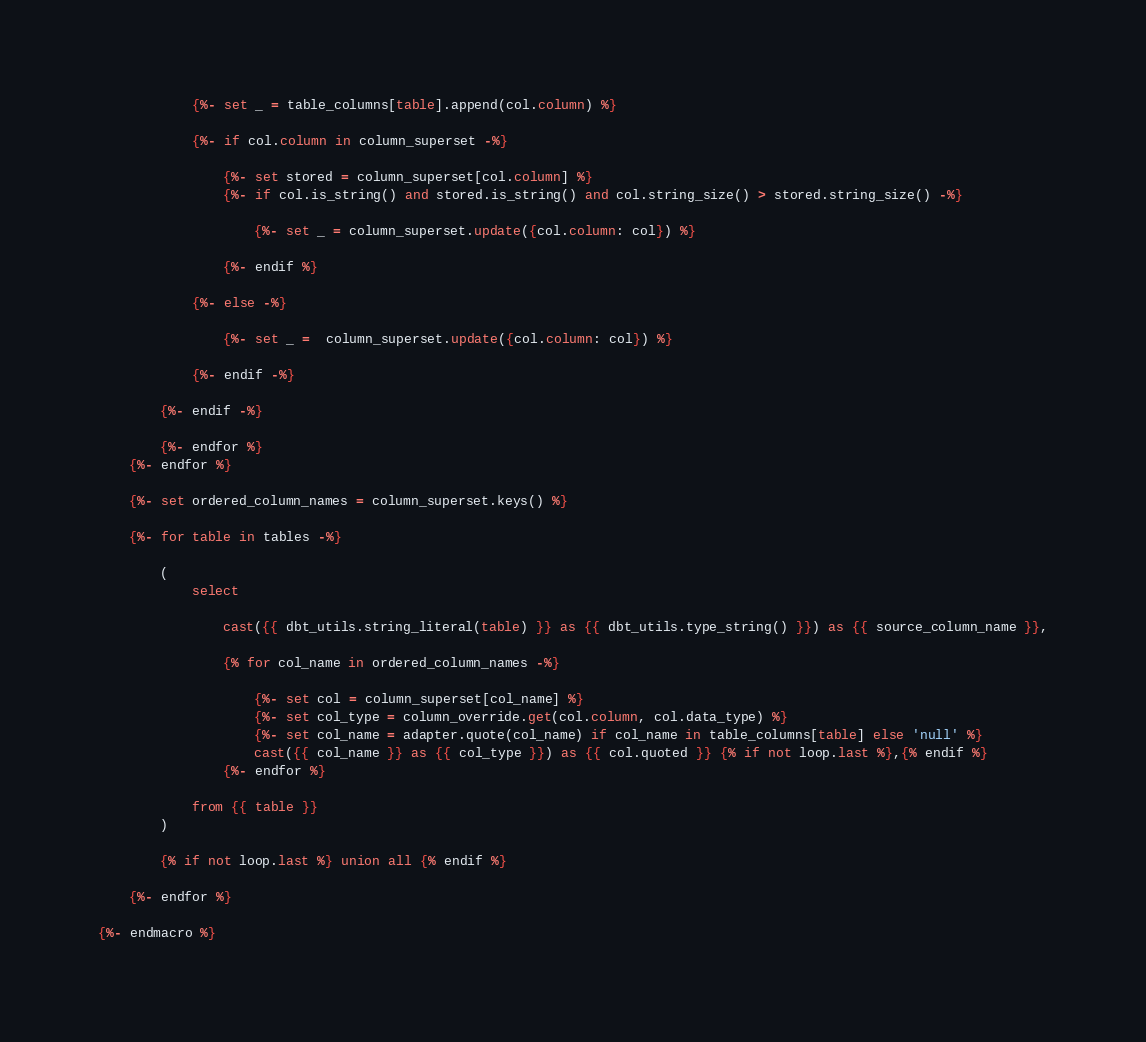<code> <loc_0><loc_0><loc_500><loc_500><_SQL_>            {%- set _ = table_columns[table].append(col.column) %}

            {%- if col.column in column_superset -%}

                {%- set stored = column_superset[col.column] %}
                {%- if col.is_string() and stored.is_string() and col.string_size() > stored.string_size() -%}

                    {%- set _ = column_superset.update({col.column: col}) %}

                {%- endif %}

            {%- else -%}

                {%- set _ =  column_superset.update({col.column: col}) %}

            {%- endif -%}

        {%- endif -%}

        {%- endfor %}
    {%- endfor %}

    {%- set ordered_column_names = column_superset.keys() %}

    {%- for table in tables -%}

        (
            select

                cast({{ dbt_utils.string_literal(table) }} as {{ dbt_utils.type_string() }}) as {{ source_column_name }},

                {% for col_name in ordered_column_names -%}

                    {%- set col = column_superset[col_name] %}
                    {%- set col_type = column_override.get(col.column, col.data_type) %}
                    {%- set col_name = adapter.quote(col_name) if col_name in table_columns[table] else 'null' %}
                    cast({{ col_name }} as {{ col_type }}) as {{ col.quoted }} {% if not loop.last %},{% endif %}
                {%- endfor %}

            from {{ table }}
        )

        {% if not loop.last %} union all {% endif %}

    {%- endfor %}

{%- endmacro %}
</code> 